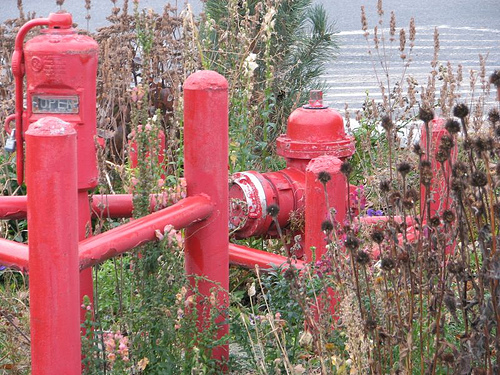Please extract the text content from this image. OPEN 